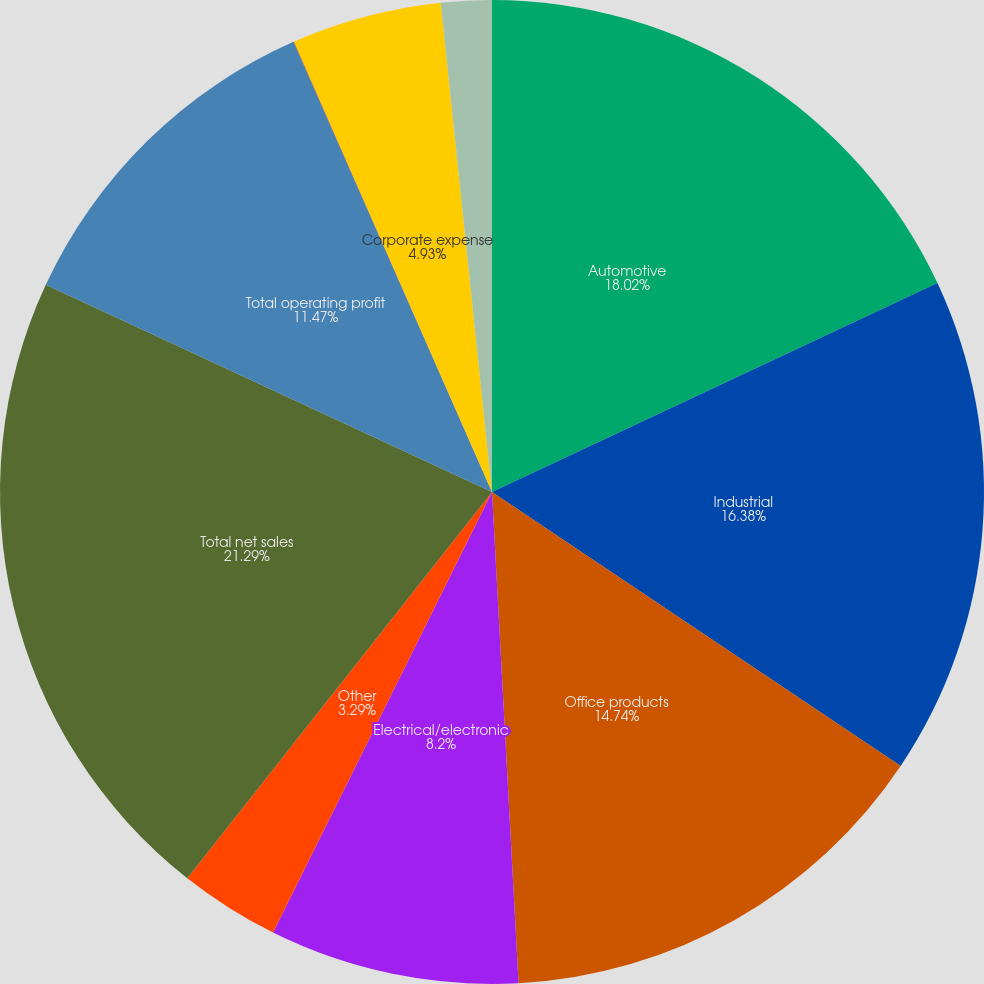<chart> <loc_0><loc_0><loc_500><loc_500><pie_chart><fcel>Automotive<fcel>Industrial<fcel>Office products<fcel>Electrical/electronic<fcel>Other<fcel>Total net sales<fcel>Total operating profit<fcel>Interest expense net<fcel>Corporate expense<fcel>Intangible asset amortization<nl><fcel>18.02%<fcel>16.38%<fcel>14.74%<fcel>8.2%<fcel>3.29%<fcel>21.29%<fcel>11.47%<fcel>0.02%<fcel>4.93%<fcel>1.66%<nl></chart> 